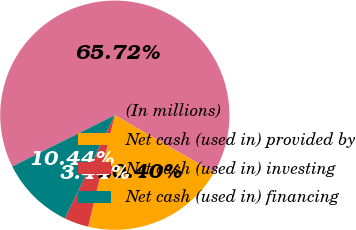Convert chart to OTSL. <chart><loc_0><loc_0><loc_500><loc_500><pie_chart><fcel>(In millions)<fcel>Net cash (used in) provided by<fcel>Net cash (used in) investing<fcel>Net cash (used in) financing<nl><fcel>65.72%<fcel>20.4%<fcel>3.44%<fcel>10.44%<nl></chart> 